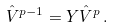<formula> <loc_0><loc_0><loc_500><loc_500>\hat { V } ^ { p - 1 } = Y \hat { V } ^ { p } \, .</formula> 